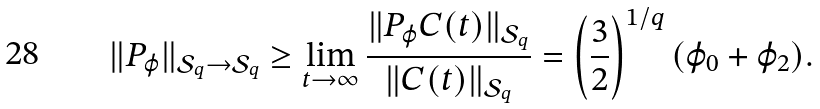Convert formula to latex. <formula><loc_0><loc_0><loc_500><loc_500>\| P _ { \varphi } \| _ { \mathcal { S } _ { q } \to \mathcal { S } _ { q } } \geq \lim _ { t \to \infty } \frac { \| P _ { \varphi } C ( t ) \| _ { \mathcal { S } _ { q } } } { \| C ( t ) \| _ { \mathcal { S } _ { q } } } = \left ( \frac { 3 } { 2 } \right ) ^ { 1 / q } ( \varphi _ { 0 } + \varphi _ { 2 } ) .</formula> 